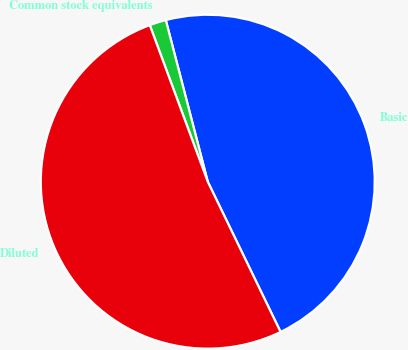Convert chart. <chart><loc_0><loc_0><loc_500><loc_500><pie_chart><fcel>Basic<fcel>Common stock equivalents<fcel>Diluted<nl><fcel>46.86%<fcel>1.6%<fcel>51.54%<nl></chart> 